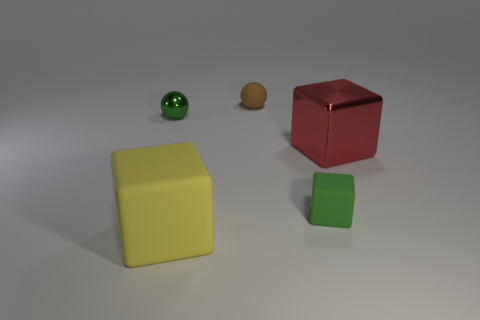Is there a blue sphere of the same size as the red shiny cube?
Provide a succinct answer. No. Are there any green matte objects right of the large red metal thing that is to the right of the block in front of the green cube?
Offer a terse response. No. There is a matte sphere; is it the same color as the small thing that is in front of the red metal thing?
Provide a succinct answer. No. The green thing on the right side of the large thing on the left side of the matte object that is behind the small green rubber cube is made of what material?
Your answer should be very brief. Rubber. What is the shape of the shiny object right of the tiny brown ball?
Offer a terse response. Cube. There is a brown ball that is made of the same material as the green block; what is its size?
Ensure brevity in your answer.  Small. How many small brown rubber objects are the same shape as the green metallic thing?
Give a very brief answer. 1. There is a large cube in front of the big shiny block; does it have the same color as the metal sphere?
Keep it short and to the point. No. There is a matte block that is to the right of the matte block that is in front of the green matte cube; how many metal objects are behind it?
Make the answer very short. 2. What number of objects are in front of the brown rubber object and behind the large shiny block?
Your response must be concise. 1. 